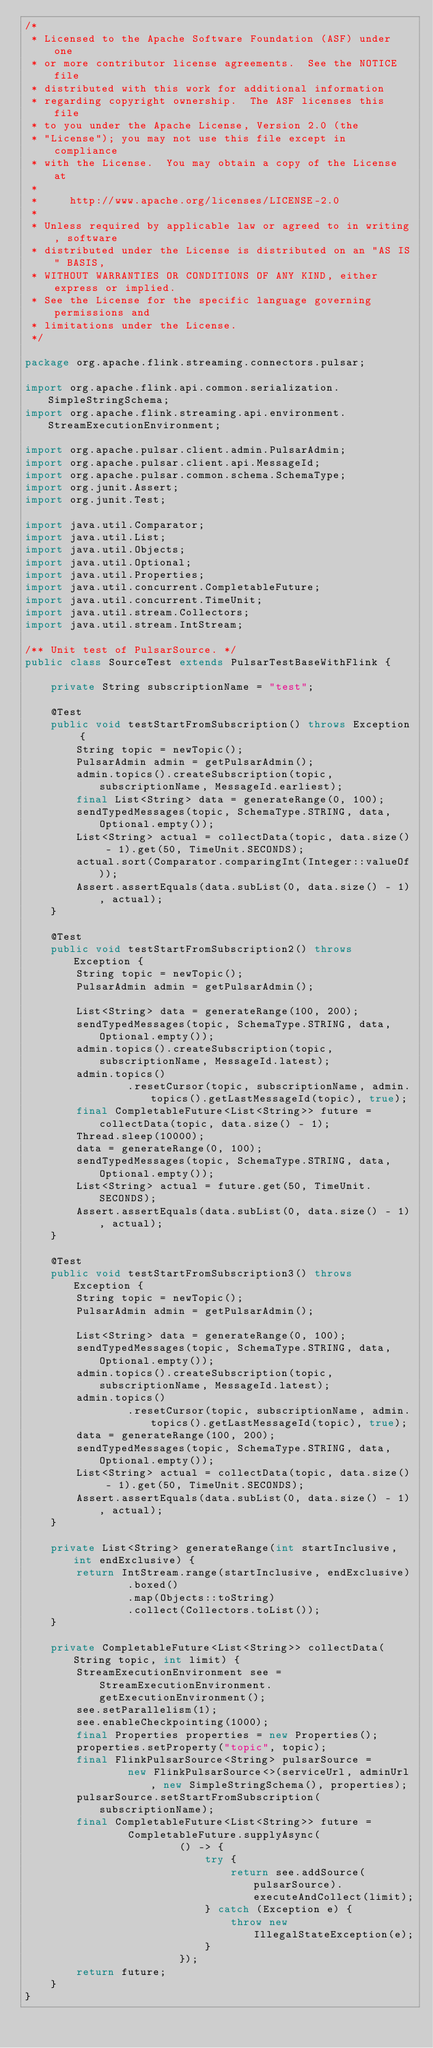Convert code to text. <code><loc_0><loc_0><loc_500><loc_500><_Java_>/*
 * Licensed to the Apache Software Foundation (ASF) under one
 * or more contributor license agreements.  See the NOTICE file
 * distributed with this work for additional information
 * regarding copyright ownership.  The ASF licenses this file
 * to you under the Apache License, Version 2.0 (the
 * "License"); you may not use this file except in compliance
 * with the License.  You may obtain a copy of the License at
 *
 *     http://www.apache.org/licenses/LICENSE-2.0
 *
 * Unless required by applicable law or agreed to in writing, software
 * distributed under the License is distributed on an "AS IS" BASIS,
 * WITHOUT WARRANTIES OR CONDITIONS OF ANY KIND, either express or implied.
 * See the License for the specific language governing permissions and
 * limitations under the License.
 */

package org.apache.flink.streaming.connectors.pulsar;

import org.apache.flink.api.common.serialization.SimpleStringSchema;
import org.apache.flink.streaming.api.environment.StreamExecutionEnvironment;

import org.apache.pulsar.client.admin.PulsarAdmin;
import org.apache.pulsar.client.api.MessageId;
import org.apache.pulsar.common.schema.SchemaType;
import org.junit.Assert;
import org.junit.Test;

import java.util.Comparator;
import java.util.List;
import java.util.Objects;
import java.util.Optional;
import java.util.Properties;
import java.util.concurrent.CompletableFuture;
import java.util.concurrent.TimeUnit;
import java.util.stream.Collectors;
import java.util.stream.IntStream;

/** Unit test of PulsarSource. */
public class SourceTest extends PulsarTestBaseWithFlink {

    private String subscriptionName = "test";

    @Test
    public void testStartFromSubscription() throws Exception {
        String topic = newTopic();
        PulsarAdmin admin = getPulsarAdmin();
        admin.topics().createSubscription(topic, subscriptionName, MessageId.earliest);
        final List<String> data = generateRange(0, 100);
        sendTypedMessages(topic, SchemaType.STRING, data, Optional.empty());
        List<String> actual = collectData(topic, data.size() - 1).get(50, TimeUnit.SECONDS);
        actual.sort(Comparator.comparingInt(Integer::valueOf));
        Assert.assertEquals(data.subList(0, data.size() - 1), actual);
    }

    @Test
    public void testStartFromSubscription2() throws Exception {
        String topic = newTopic();
        PulsarAdmin admin = getPulsarAdmin();

        List<String> data = generateRange(100, 200);
        sendTypedMessages(topic, SchemaType.STRING, data, Optional.empty());
        admin.topics().createSubscription(topic, subscriptionName, MessageId.latest);
        admin.topics()
                .resetCursor(topic, subscriptionName, admin.topics().getLastMessageId(topic), true);
        final CompletableFuture<List<String>> future = collectData(topic, data.size() - 1);
        Thread.sleep(10000);
        data = generateRange(0, 100);
        sendTypedMessages(topic, SchemaType.STRING, data, Optional.empty());
        List<String> actual = future.get(50, TimeUnit.SECONDS);
        Assert.assertEquals(data.subList(0, data.size() - 1), actual);
    }

    @Test
    public void testStartFromSubscription3() throws Exception {
        String topic = newTopic();
        PulsarAdmin admin = getPulsarAdmin();

        List<String> data = generateRange(0, 100);
        sendTypedMessages(topic, SchemaType.STRING, data, Optional.empty());
        admin.topics().createSubscription(topic, subscriptionName, MessageId.latest);
        admin.topics()
                .resetCursor(topic, subscriptionName, admin.topics().getLastMessageId(topic), true);
        data = generateRange(100, 200);
        sendTypedMessages(topic, SchemaType.STRING, data, Optional.empty());
        List<String> actual = collectData(topic, data.size() - 1).get(50, TimeUnit.SECONDS);
        Assert.assertEquals(data.subList(0, data.size() - 1), actual);
    }

    private List<String> generateRange(int startInclusive, int endExclusive) {
        return IntStream.range(startInclusive, endExclusive)
                .boxed()
                .map(Objects::toString)
                .collect(Collectors.toList());
    }

    private CompletableFuture<List<String>> collectData(String topic, int limit) {
        StreamExecutionEnvironment see = StreamExecutionEnvironment.getExecutionEnvironment();
        see.setParallelism(1);
        see.enableCheckpointing(1000);
        final Properties properties = new Properties();
        properties.setProperty("topic", topic);
        final FlinkPulsarSource<String> pulsarSource =
                new FlinkPulsarSource<>(serviceUrl, adminUrl, new SimpleStringSchema(), properties);
        pulsarSource.setStartFromSubscription(subscriptionName);
        final CompletableFuture<List<String>> future =
                CompletableFuture.supplyAsync(
                        () -> {
                            try {
                                return see.addSource(pulsarSource).executeAndCollect(limit);
                            } catch (Exception e) {
                                throw new IllegalStateException(e);
                            }
                        });
        return future;
    }
}
</code> 